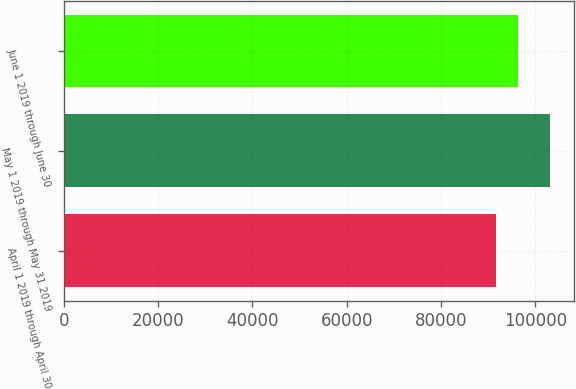Convert chart. <chart><loc_0><loc_0><loc_500><loc_500><bar_chart><fcel>April 1 2019 through April 30<fcel>May 1 2019 through May 31 2019<fcel>June 1 2019 through June 30<nl><fcel>91600<fcel>103000<fcel>96283<nl></chart> 